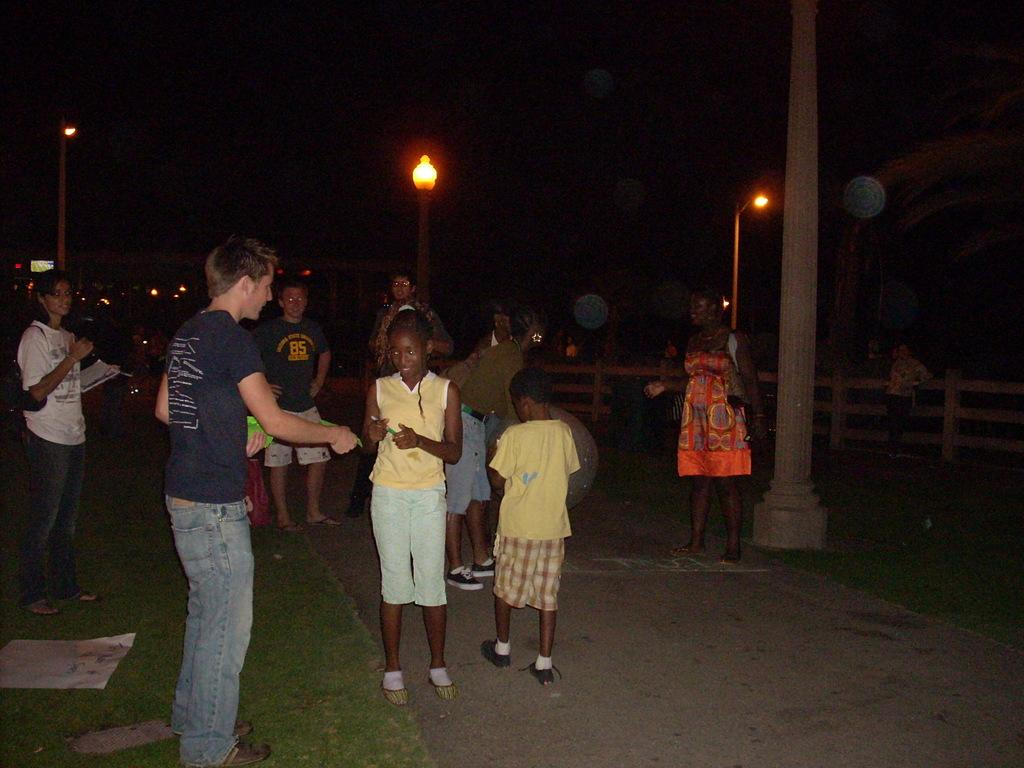What is the main subject in the foreground of the image? There is a crowd in the foreground of the image. Where is the crowd located? The crowd is on the road. What type of vegetation is present in the foreground of the image? Grass is present in the foreground of the image. What can be seen in the background of the image? There is a fence, light poles, and the sky visible in the background of the image. What time of day is the image taken? The image is taken during night. How many visitors are exchanging connections in the image? There is no mention of visitors or connections being exchanged in the image. The image features a crowd on the road during night, with a fence, light poles, and the sky visible in the background. 